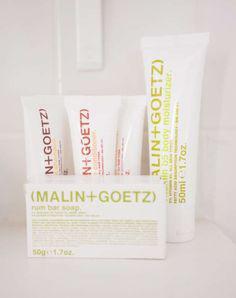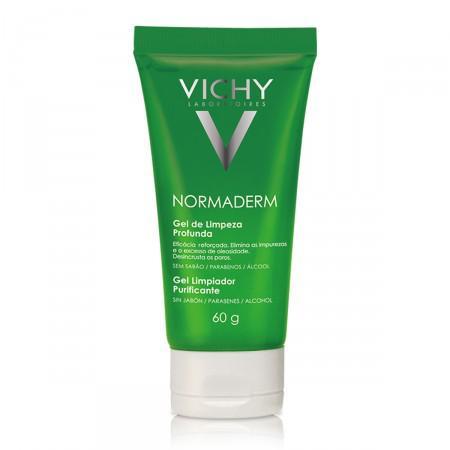The first image is the image on the left, the second image is the image on the right. For the images shown, is this caption "In at least one image, there is a green tube with a white cap next to a green box packaging" true? Answer yes or no. No. The first image is the image on the left, the second image is the image on the right. Given the left and right images, does the statement "Two tubes of body moisturing products are stood on cap end, one in each image, one of them beside a box in which the product may be sold." hold true? Answer yes or no. No. 